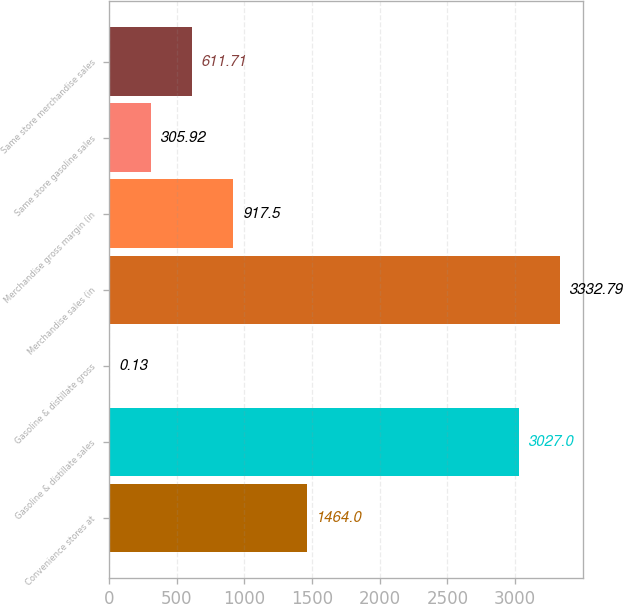<chart> <loc_0><loc_0><loc_500><loc_500><bar_chart><fcel>Convenience stores at<fcel>Gasoline & distillate sales<fcel>Gasoline & distillate gross<fcel>Merchandise sales (in<fcel>Merchandise gross margin (in<fcel>Same store gasoline sales<fcel>Same store merchandise sales<nl><fcel>1464<fcel>3027<fcel>0.13<fcel>3332.79<fcel>917.5<fcel>305.92<fcel>611.71<nl></chart> 